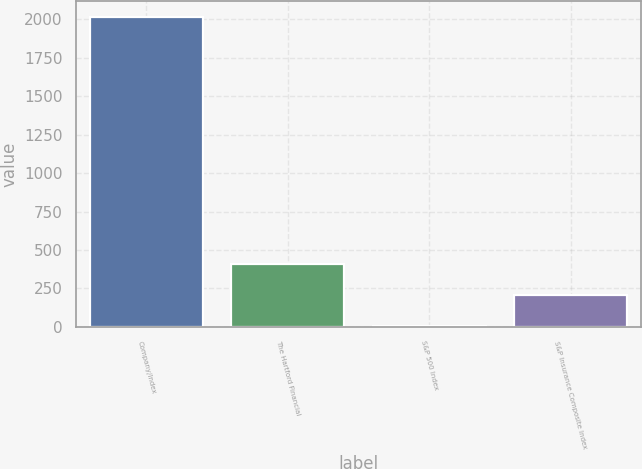Convert chart to OTSL. <chart><loc_0><loc_0><loc_500><loc_500><bar_chart><fcel>Company/Index<fcel>The Hartford Financial<fcel>S&P 500 Index<fcel>S&P Insurance Composite Index<nl><fcel>2018<fcel>407.1<fcel>4.38<fcel>205.74<nl></chart> 